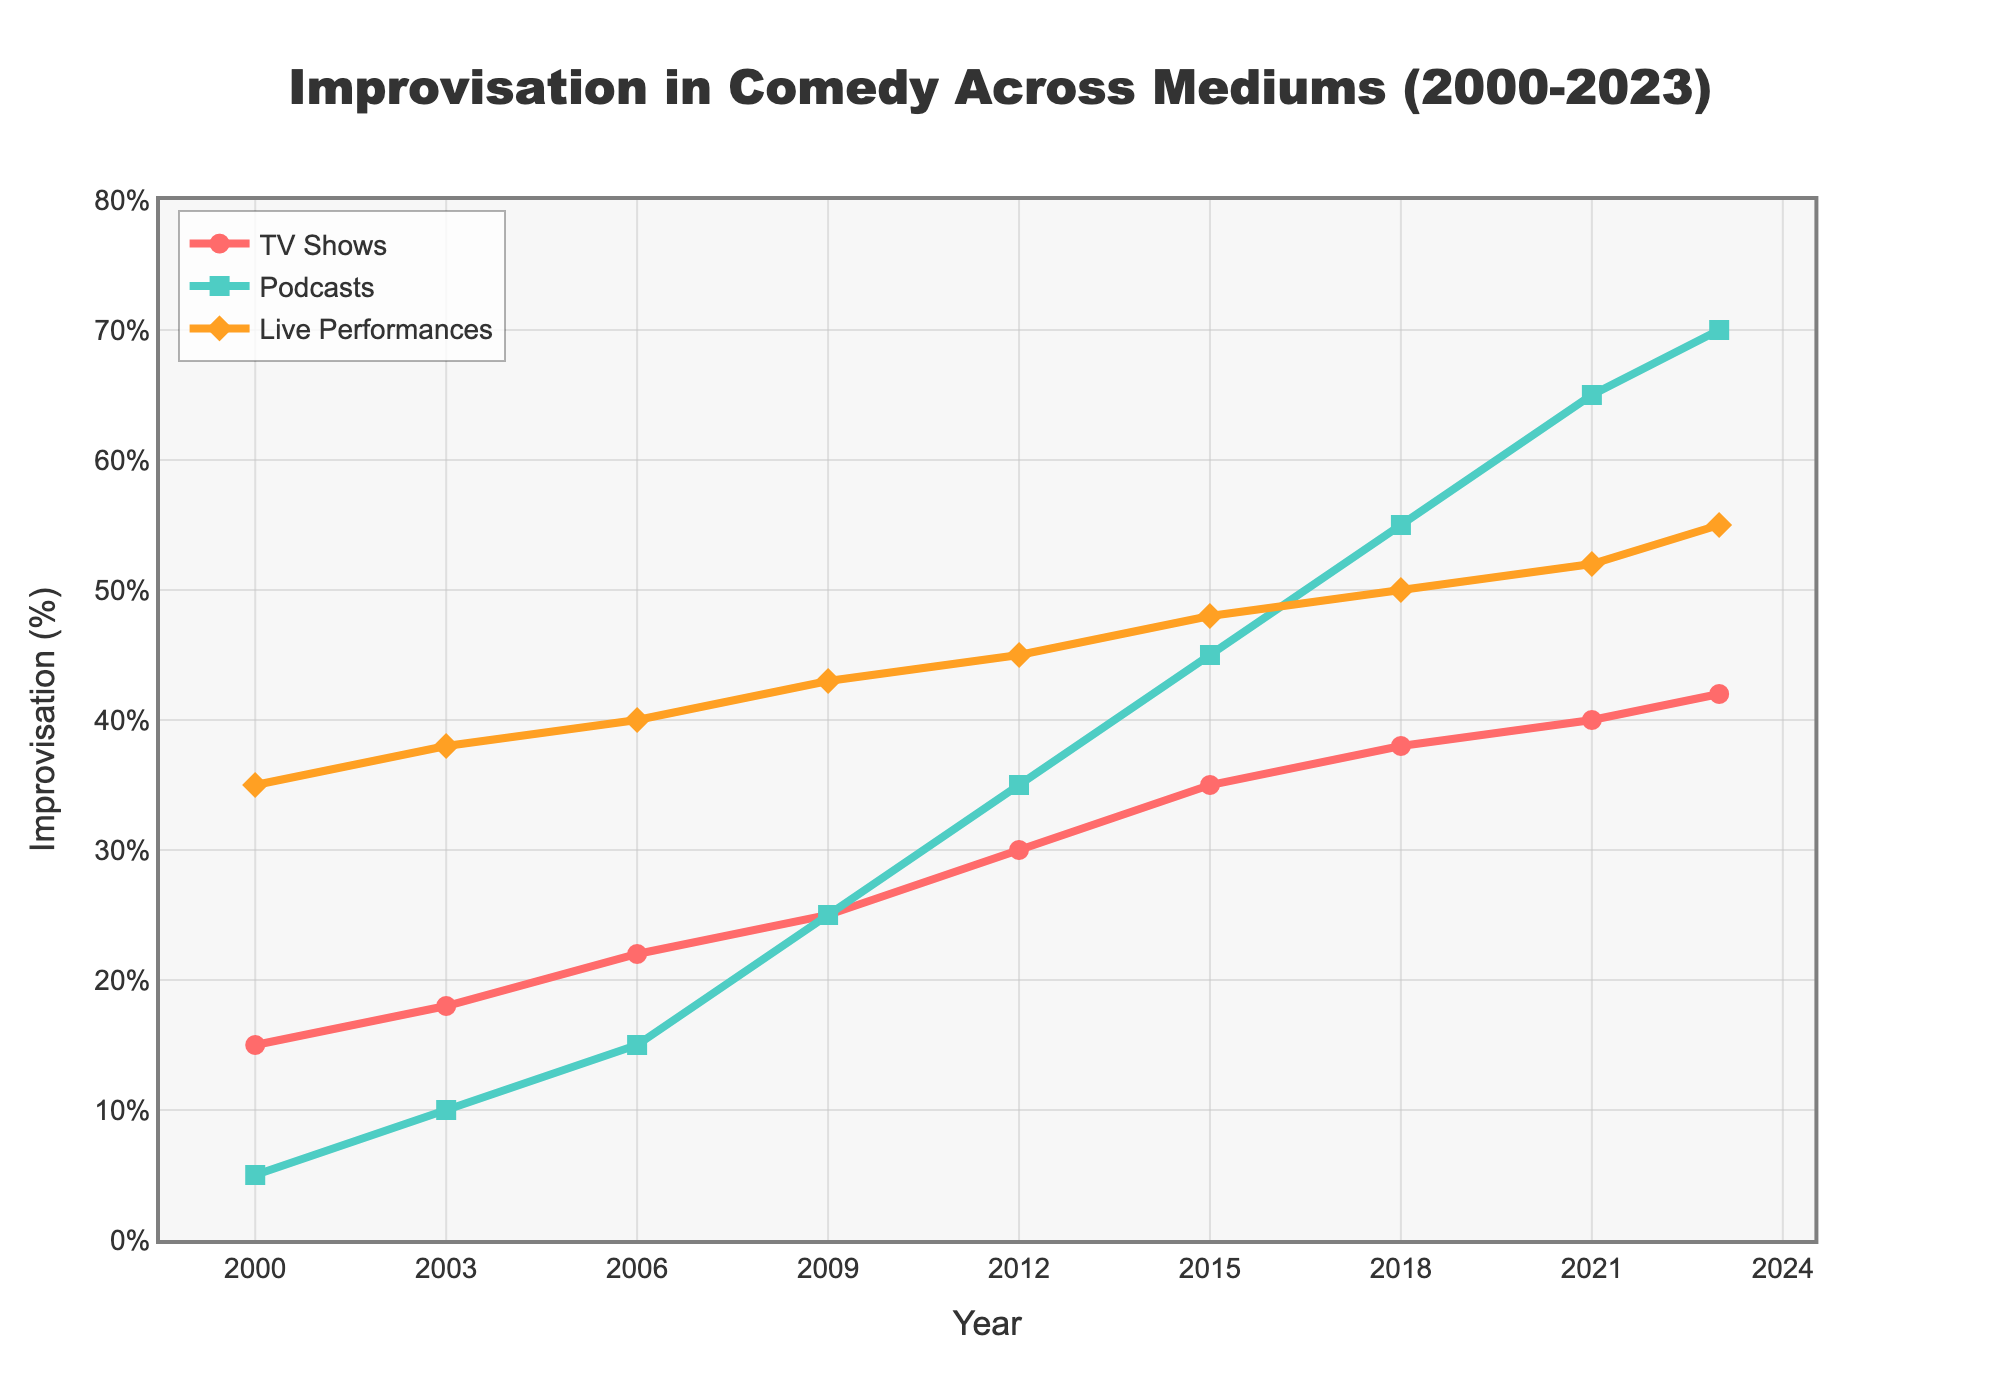Why does the percentage of improvisation in TV Shows increase from 2012 to 2023? The chart shows an upward trend in the percentage of improvisation in TV shows from around 30% in 2012 to 42% in 2023, indicating a growing trend towards unscripted content in TV comedy. This could be influenced by a variety of factors such as audience preference for authentic and spontaneous humor or changes in production practices.
Answer: Increasing trend from 30% to 42% Which medium had the highest percentage of improvisation in 2023? According to the figure, live performances had the highest percentage of improvisation in 2023, with a value of 55%.
Answer: Live performances (55%) Compare the percentage increase in improvisation for podcasts and TV shows between 2000 and 2023. For TV shows, the improvisation percentage increased from 15% in 2000 to 42% in 2023. This is an increase of 27%. For podcasts, the improvisation percentage increased from 5% in 2000 to 70% in 2023. This is an increase of 65%.
Answer: TV Shows: 27%, Podcasts: 65% What can be inferred about the trend of improvisation in live performances from 2000 to 2023? The figure shows that the percentage of improvisation in live performances has gradually increased from 35% in 2000 to 55% in 2023. This indicates a consistent growth in the use of improvisation in live comedy acts.
Answer: Consistent growth What year did podcasts see the most significant jump in improvisation percentage? The figure indicates that the most significant jump in the percentage of improvisation for podcasts occurred between 2012 (35%) and 2015 (45%), a 10% increase.
Answer: Between 2012 and 2015 Calculate the average percentage of improvisation for TV shows over the period 2000 to 2023. To find the average, add the percentages for each year (15+18+22+25+30+35+38+40+42) and divide by the number of years (9). The sum is 265, so the average is 265/9 ≈ 29.44%.
Answer: 29.44% Which period saw a greater increase in the percentage of improvisation in TV shows: 2000-2012 or 2012-2023? For 2000-2012, the increase is from 15% to 30%, which is 15%. For 2012-2023, the increase is from 30% to 42%, which is 12%. Hence, the period 2000-2012 saw a greater increase.
Answer: 2000-2012 How does the trend in TV shows compare visually to that in live performances? Visually, both mediums show an increasing trend in improvisation, but live performances started and remained consistently higher than TV shows. TV shows’ line is red and has a steeper upward curve post-2012, while the line for live performances is orange and more gradual.
Answer: Live performances consistently higher, TV shows' steeper increase What is the overall trend for all three mediums from 2000 to 2023? The overall trend for TV shows, podcasts, and live performances from 2000 to 2023 is an increase in the percentage of improvisation, suggesting a widespread shift towards more unscripted content across all mediums.
Answer: Overall increasing trend 